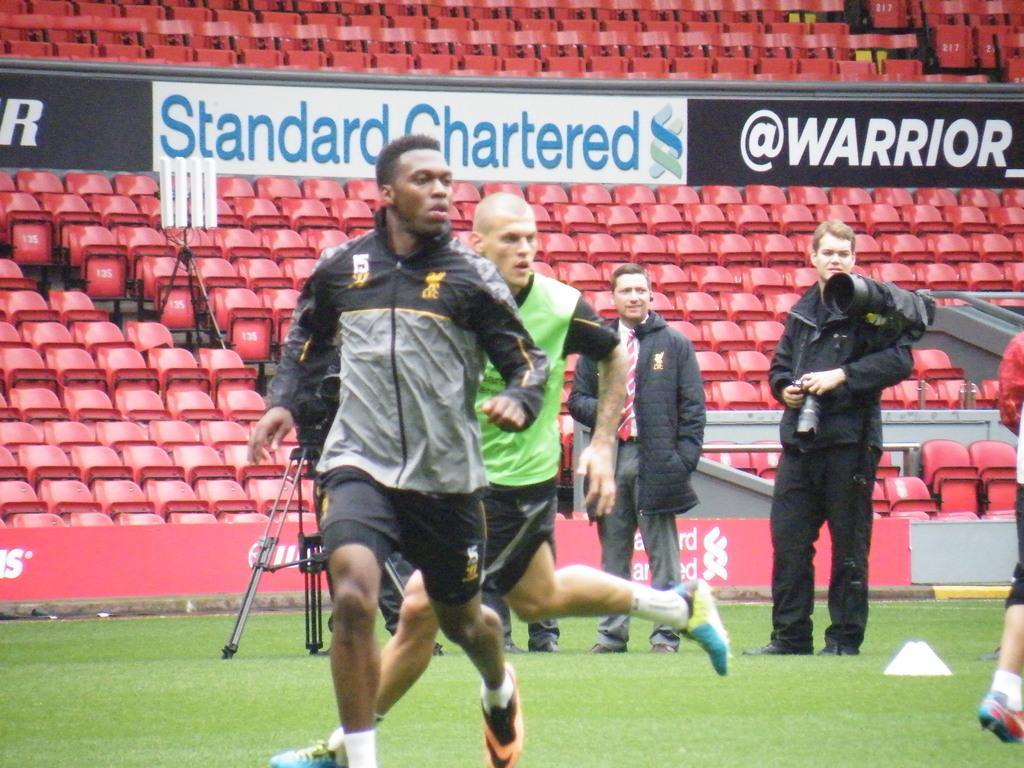Describe this image in one or two sentences. In this image, we can see people wearing sports dress and some are wearing coats, one of them is holding a camera. In the background, there are boards and we can see chairs and stands. At the bottom, there is ground. 